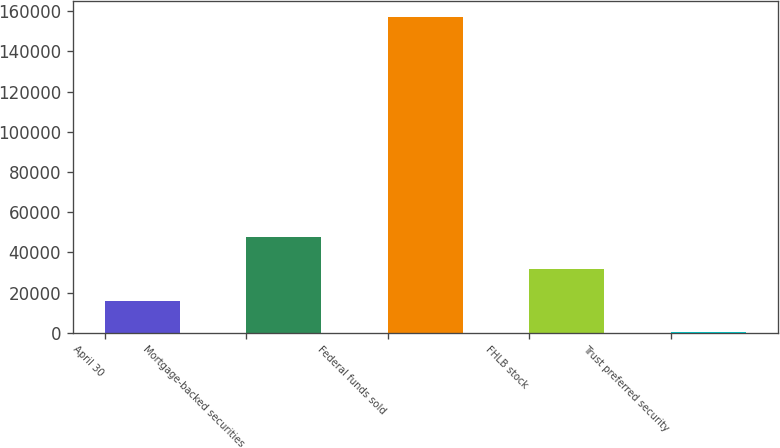Convert chart to OTSL. <chart><loc_0><loc_0><loc_500><loc_500><bar_chart><fcel>April 30<fcel>Mortgage-backed securities<fcel>Federal funds sold<fcel>FHLB stock<fcel>Trust preferred security<nl><fcel>15995.4<fcel>47402.2<fcel>157326<fcel>31698.8<fcel>292<nl></chart> 